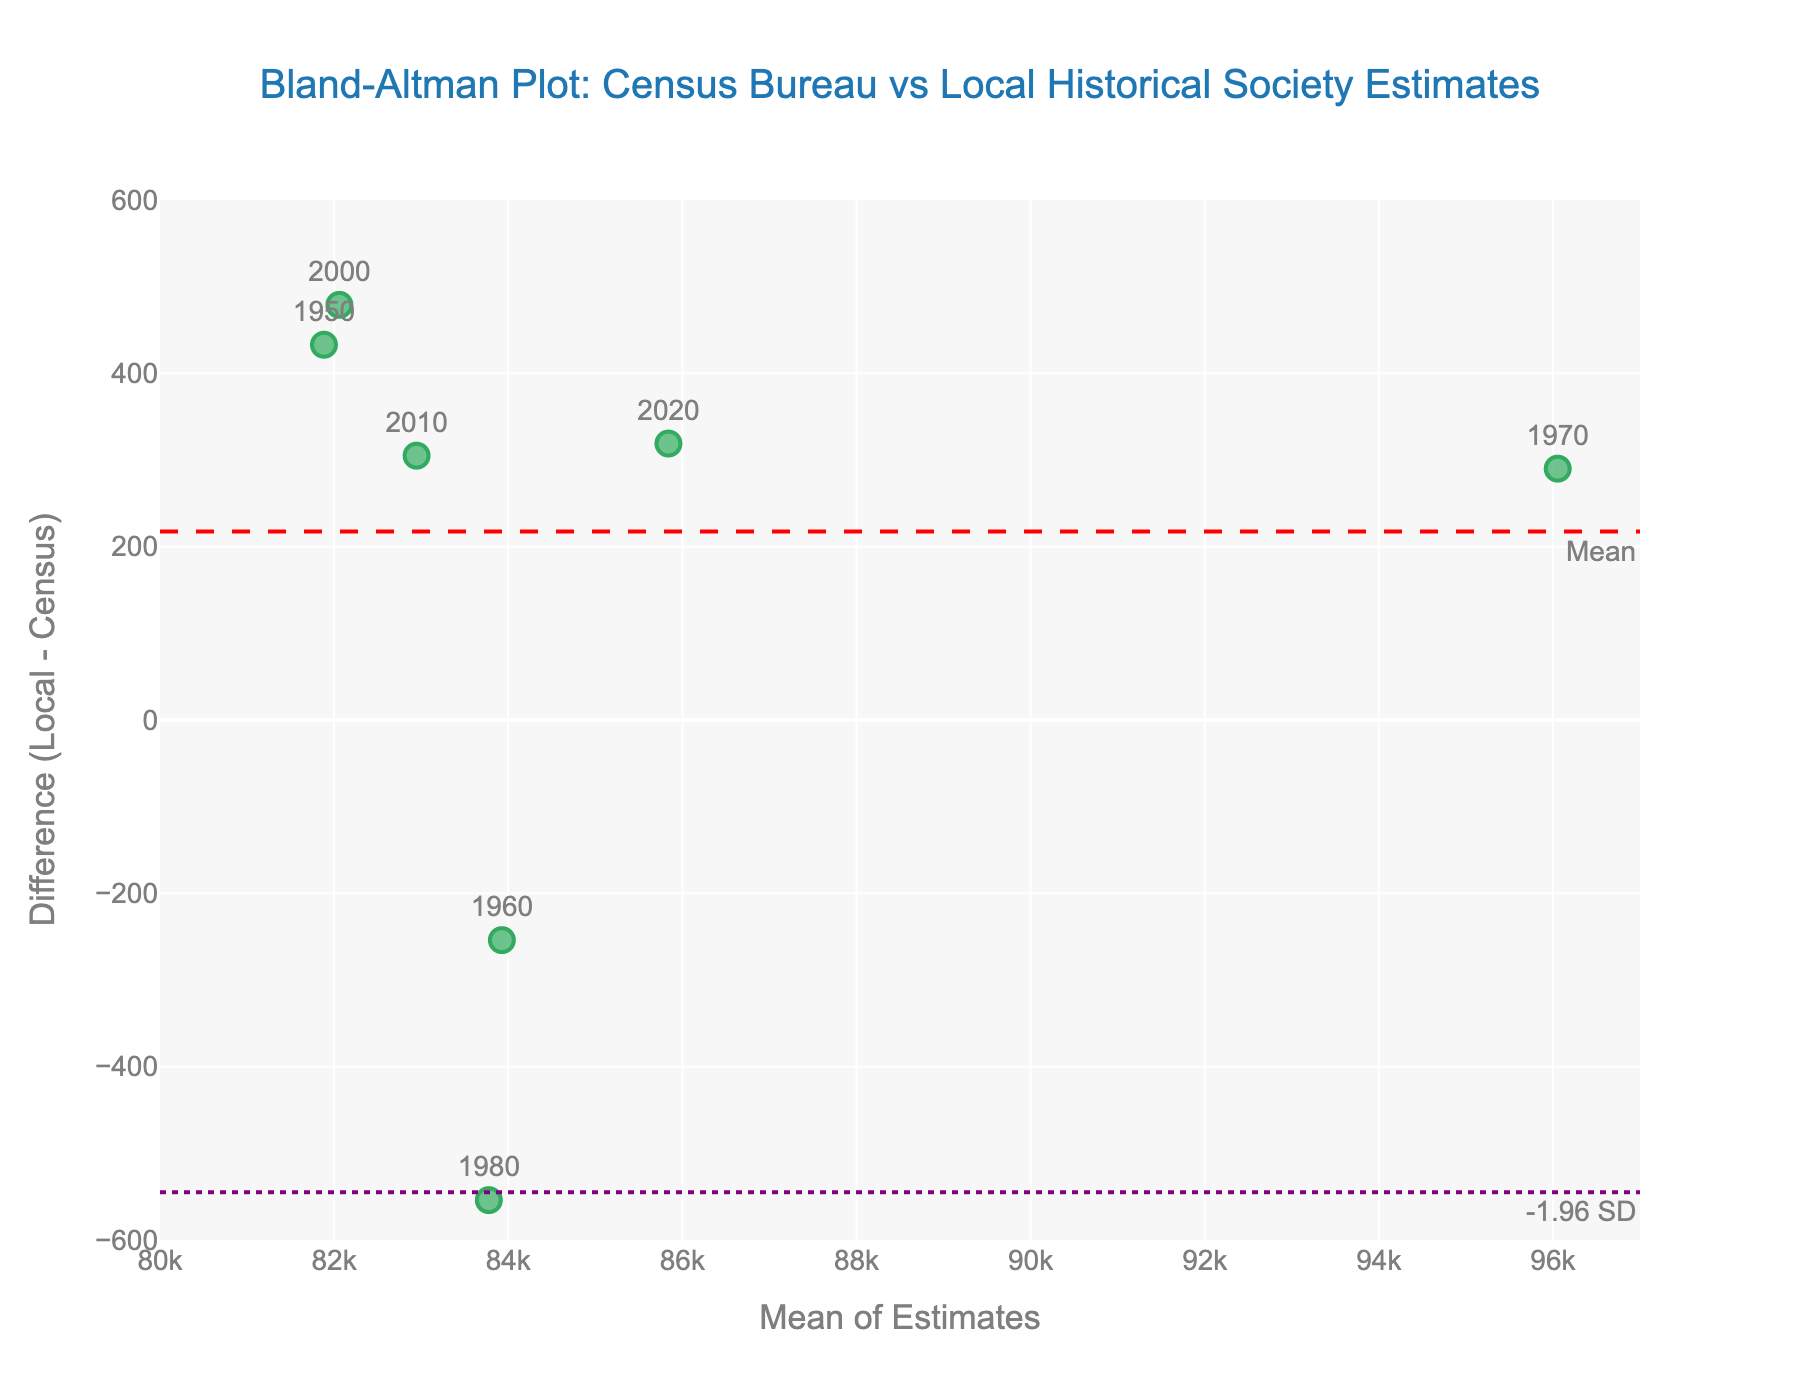What's the title of the figure? The title of the figure is displayed at the top and reads: "Bland-Altman Plot: Census Bureau vs Local Historical Society Estimates".
Answer: Bland-Altman Plot: Census Bureau vs Local Historical Society Estimates What are the x-axis and y-axis titles? The x-axis title, placed at the bottom of the plot, is "Mean of Estimates," and the y-axis title, located on the left side of the plot, is "Difference (Local - Census)".
Answer: Mean of Estimates; Difference (Local - Census) What's the color and style of the line representing the mean difference? The mean difference line is shown in red with a dashed style.
Answer: Red, dashed How many sources are represented in the plot? Each source is marked by a green dot, and there is one for each year. Counting these reveals there are 8 data points.
Answer: 8 What's the range set for the x-axis on the plot? The x-axis range starts at 80,000 and ends at 97,000, as observed on the plot's axis.
Answer: 80,000 to 97,000 What is the mean difference between the local historical society and the Census Bureau estimates? The mean difference line is labeled "Mean" in red and annotated at the corresponding y-value. The mean difference is the average difference between the local historical society's estimates and the Census Bureau estimates across all years. Inspecting the plot, it appears at approximately 10.
Answer: 10 Which year has the smallest difference between the local historical society and Census Bureau estimates? By examining the y-values on the plot, the smallest difference is the data closest to 0. The point labeled 1960 has a very small positive difference.
Answer: 1960 How many data points fall within ±1.96 standard deviations of the mean difference? The ±1.96 SD lines are indicated by purple dotted lines. Counting the data points that fall between these lines, all 8 points are within this range.
Answer: 8 What is the difference between the highest and lowest y-values in the plot? The highest y-value appeared for the year 1990, which is approximately 720, and the lowest for the year 1980, about -580. The difference calculated is around 720 - (-580) = 1300.
Answer: 1300 What is the average of the means of estimates? Adding the mean estimates for all years and dividing by the number of points: (81,883.5 + 83,927 + 96,055 + 83,277 + 81,538.5 + 82,060.5 + 82,947.5 + 85,840.5) / 8 = 84,566.875.
Answer: 84,566.875 